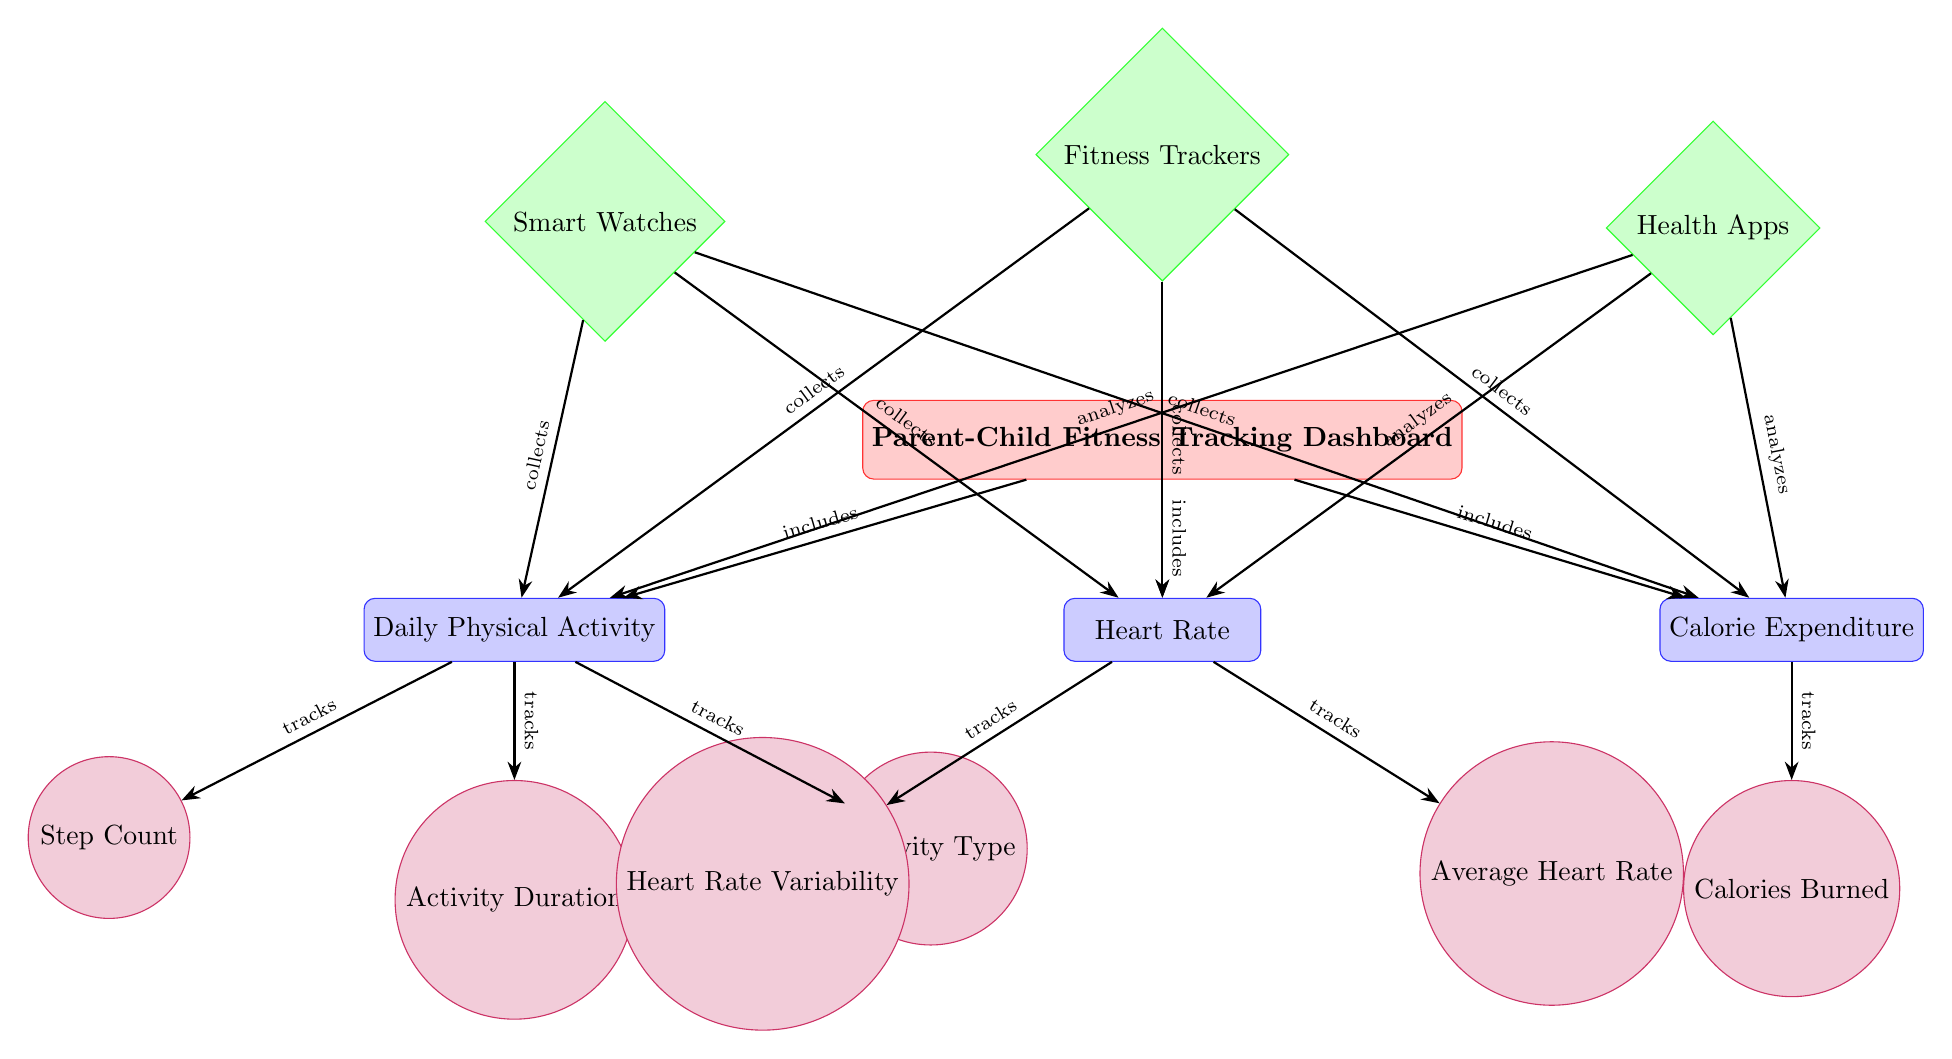What is the main element of the diagram? The central node labeled "Parent-Child Fitness Tracking Dashboard" represents the main element of the diagram, indicating that it is the core focus.
Answer: Parent-Child Fitness Tracking Dashboard How many categories are present in the diagram? There are three categories listed: Daily Physical Activity, Heart Rate, and Calorie Expenditure. Thus, the answer is obtained by counting the categories.
Answer: 3 Which device collects data about heart rate? The arrows show that both Smart Watches and Fitness Trackers collect data related to heart rate, but since the question requests a single answer, I will refer to Smart Watches as they are typically known for heart-related tracking.
Answer: Smart Watches What metric tracks the duration of activity? The metric labeled "Activity Duration" is specifically identified under the Daily Physical Activity category, making it clear that it tracks activity duration.
Answer: Activity Duration What relationship exists between Health Apps and calorie expenditure? The diagram indicates that Health Apps analyze data related to calorie expenditure, showing a direct connection where the apps take data from the calorie expenditure category for analysis purposes.
Answer: Analyzes How does the Calorie Expenditure category measure its total? The Calorie Expenditure category has only one metric, which is "Calories Burned," indicating that this metric tracks the total calorie expenditures accurately.
Answer: Calories Burned Which devices collect information about all three categories? According to the diagram, both Smart Watches and Fitness Trackers collect data on Daily Physical Activity, Heart Rate, and Calorie Expenditure, as indicated by the arrows connecting them to each category.
Answer: Smart Watches and Fitness Trackers What metrics are included under Daily Physical Activity? The metrics listed under Daily Physical Activity are Step Count, Activity Duration, and Activity Type. These metrics are clearly delineated in the diagram by their positioning under the category.
Answer: Step Count, Activity Duration, Activity Type Which metric is included in the Heart Rate category? The Heart Rate category includes two metrics: Heart Rate Variability and Average Heart Rate, both of which are shown beneath the Heart Rate category in the diagram.
Answer: Heart Rate Variability and Average Heart Rate 